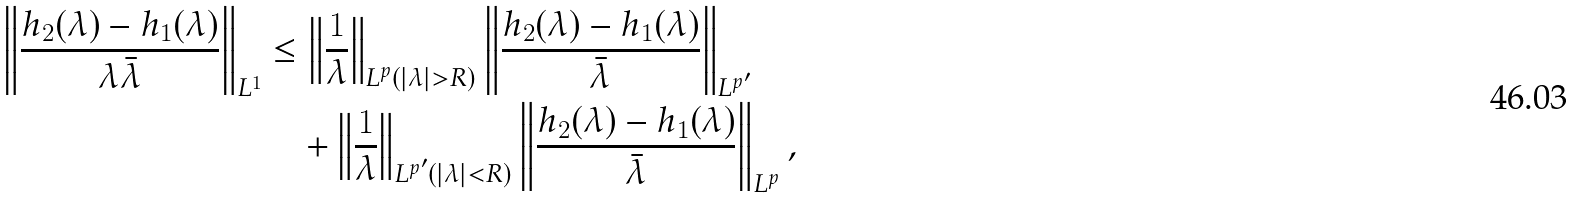Convert formula to latex. <formula><loc_0><loc_0><loc_500><loc_500>\left \| \frac { h _ { 2 } ( \lambda ) - h _ { 1 } ( \lambda ) } { \lambda \bar { \lambda } } \right \| _ { L ^ { 1 } } & \leq \left \| \frac { 1 } { \lambda } \right \| _ { L ^ { p } ( | \lambda | > R ) } \left \| \frac { h _ { 2 } ( \lambda ) - h _ { 1 } ( \lambda ) } { \bar { \lambda } } \right \| _ { L ^ { p ^ { \prime } } } \\ & \quad + \left \| \frac { 1 } { \lambda } \right \| _ { L ^ { p ^ { \prime } } ( | \lambda | < R ) } \left \| \frac { h _ { 2 } ( \lambda ) - h _ { 1 } ( \lambda ) } { \bar { \lambda } } \right \| _ { L ^ { p } } ,</formula> 